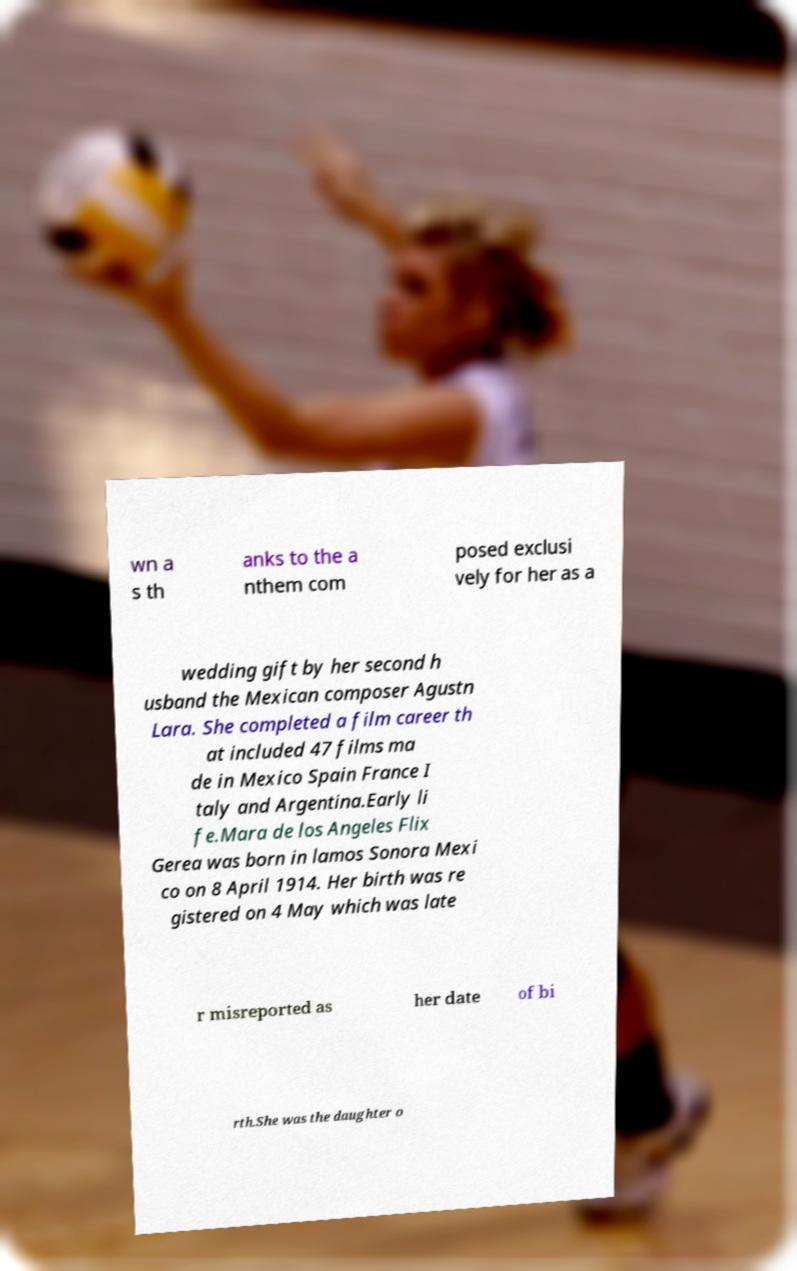Could you extract and type out the text from this image? wn a s th anks to the a nthem com posed exclusi vely for her as a wedding gift by her second h usband the Mexican composer Agustn Lara. She completed a film career th at included 47 films ma de in Mexico Spain France I taly and Argentina.Early li fe.Mara de los Angeles Flix Gerea was born in lamos Sonora Mexi co on 8 April 1914. Her birth was re gistered on 4 May which was late r misreported as her date of bi rth.She was the daughter o 